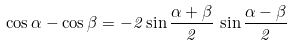Convert formula to latex. <formula><loc_0><loc_0><loc_500><loc_500>\cos \alpha - \cos \beta = - 2 \sin \frac { \alpha + \beta } { 2 } \, \sin \frac { \alpha - \beta } { 2 }</formula> 